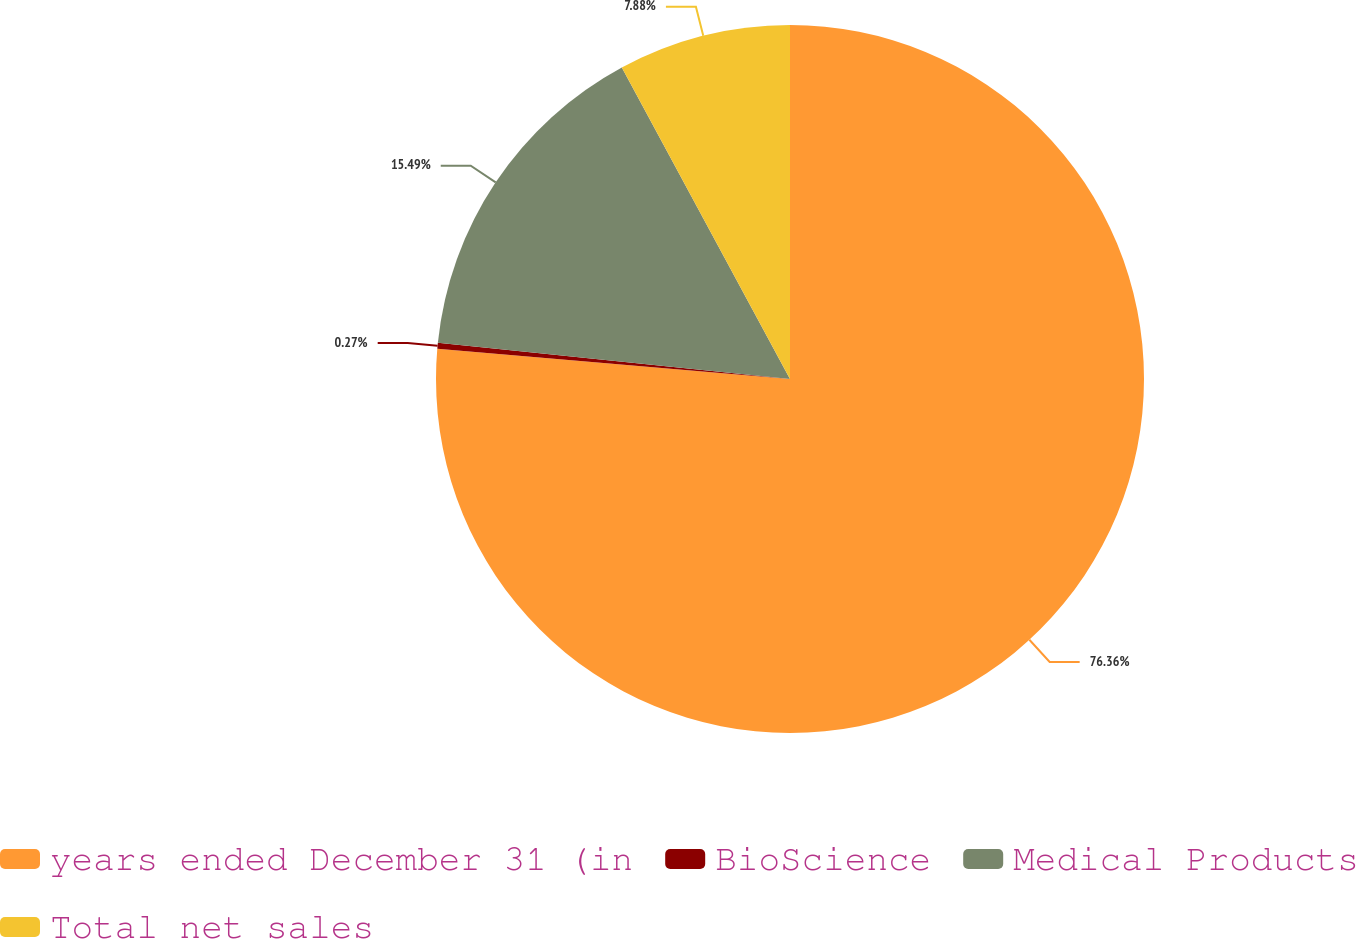Convert chart to OTSL. <chart><loc_0><loc_0><loc_500><loc_500><pie_chart><fcel>years ended December 31 (in<fcel>BioScience<fcel>Medical Products<fcel>Total net sales<nl><fcel>76.37%<fcel>0.27%<fcel>15.49%<fcel>7.88%<nl></chart> 